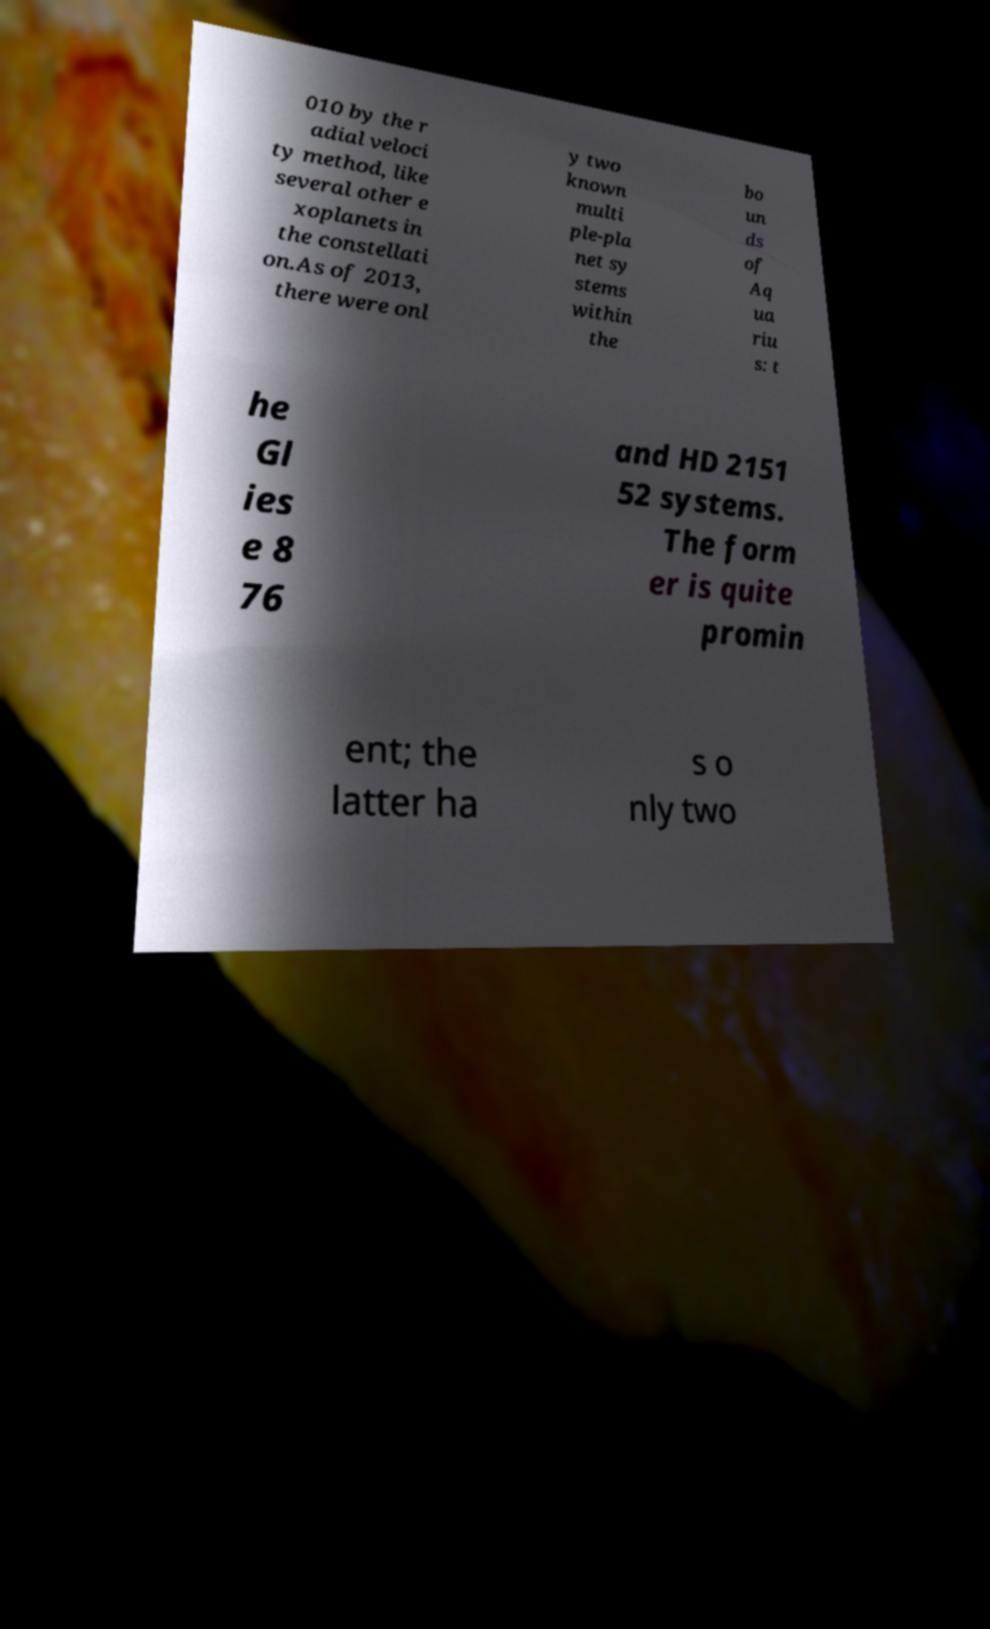For documentation purposes, I need the text within this image transcribed. Could you provide that? 010 by the r adial veloci ty method, like several other e xoplanets in the constellati on.As of 2013, there were onl y two known multi ple-pla net sy stems within the bo un ds of Aq ua riu s: t he Gl ies e 8 76 and HD 2151 52 systems. The form er is quite promin ent; the latter ha s o nly two 